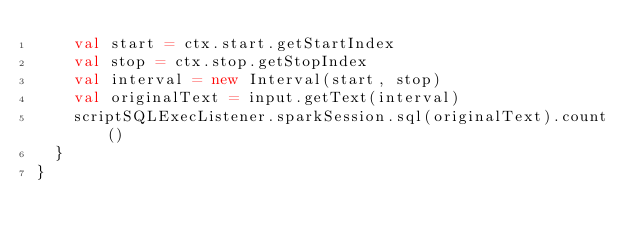Convert code to text. <code><loc_0><loc_0><loc_500><loc_500><_Scala_>    val start = ctx.start.getStartIndex
    val stop = ctx.stop.getStopIndex
    val interval = new Interval(start, stop)
    val originalText = input.getText(interval)
    scriptSQLExecListener.sparkSession.sql(originalText).count()
  }
}
</code> 